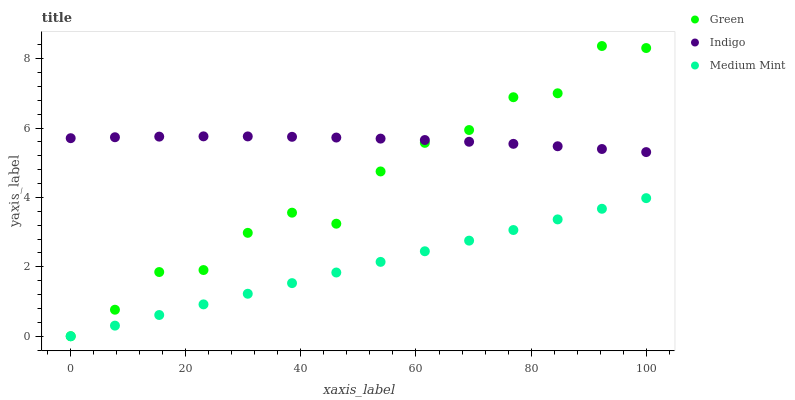Does Medium Mint have the minimum area under the curve?
Answer yes or no. Yes. Does Indigo have the maximum area under the curve?
Answer yes or no. Yes. Does Green have the minimum area under the curve?
Answer yes or no. No. Does Green have the maximum area under the curve?
Answer yes or no. No. Is Medium Mint the smoothest?
Answer yes or no. Yes. Is Green the roughest?
Answer yes or no. Yes. Is Indigo the smoothest?
Answer yes or no. No. Is Indigo the roughest?
Answer yes or no. No. Does Medium Mint have the lowest value?
Answer yes or no. Yes. Does Indigo have the lowest value?
Answer yes or no. No. Does Green have the highest value?
Answer yes or no. Yes. Does Indigo have the highest value?
Answer yes or no. No. Is Medium Mint less than Indigo?
Answer yes or no. Yes. Is Indigo greater than Medium Mint?
Answer yes or no. Yes. Does Green intersect Medium Mint?
Answer yes or no. Yes. Is Green less than Medium Mint?
Answer yes or no. No. Is Green greater than Medium Mint?
Answer yes or no. No. Does Medium Mint intersect Indigo?
Answer yes or no. No. 